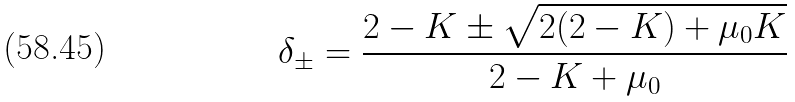<formula> <loc_0><loc_0><loc_500><loc_500>\delta _ { \pm } = \frac { 2 - K \pm \sqrt { 2 ( 2 - K ) + \mu _ { 0 } K } } { 2 - K + \mu _ { 0 } }</formula> 